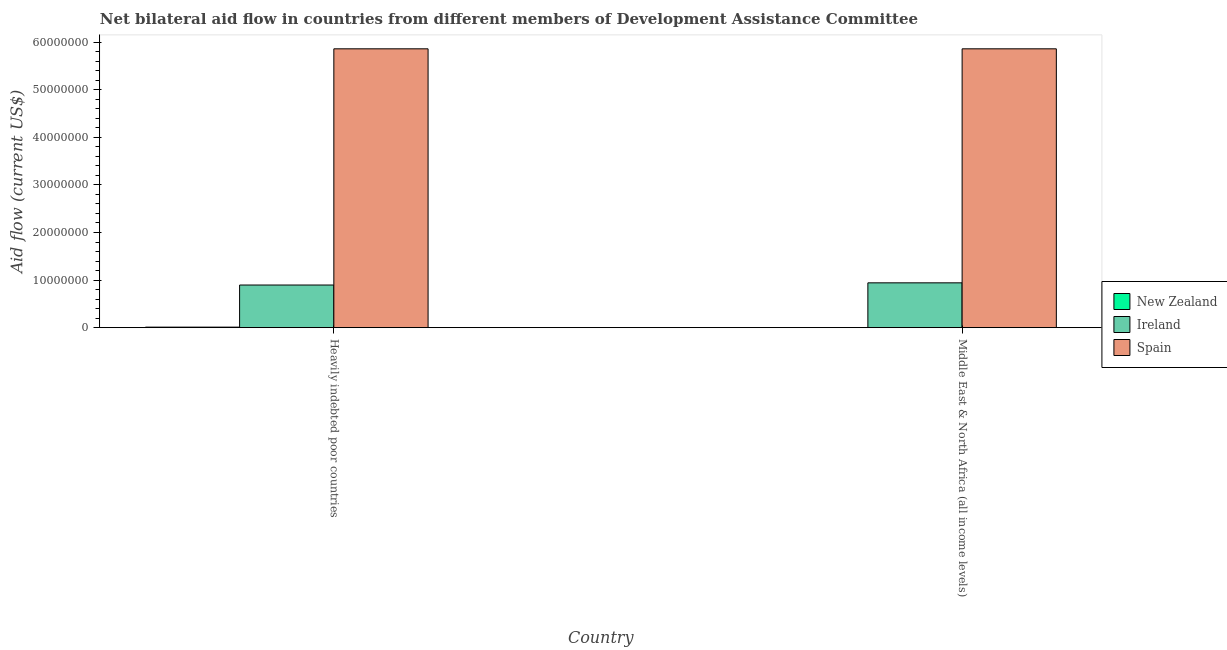How many groups of bars are there?
Offer a very short reply. 2. Are the number of bars on each tick of the X-axis equal?
Provide a succinct answer. Yes. How many bars are there on the 1st tick from the left?
Ensure brevity in your answer.  3. How many bars are there on the 1st tick from the right?
Your answer should be compact. 3. What is the label of the 1st group of bars from the left?
Provide a succinct answer. Heavily indebted poor countries. What is the amount of aid provided by ireland in Middle East & North Africa (all income levels)?
Offer a terse response. 9.42e+06. Across all countries, what is the maximum amount of aid provided by ireland?
Provide a succinct answer. 9.42e+06. Across all countries, what is the minimum amount of aid provided by new zealand?
Your answer should be compact. 3.00e+04. In which country was the amount of aid provided by ireland maximum?
Offer a very short reply. Middle East & North Africa (all income levels). In which country was the amount of aid provided by spain minimum?
Your answer should be very brief. Heavily indebted poor countries. What is the total amount of aid provided by new zealand in the graph?
Ensure brevity in your answer.  1.40e+05. What is the difference between the amount of aid provided by new zealand in Heavily indebted poor countries and that in Middle East & North Africa (all income levels)?
Make the answer very short. 8.00e+04. What is the difference between the amount of aid provided by ireland in Heavily indebted poor countries and the amount of aid provided by spain in Middle East & North Africa (all income levels)?
Keep it short and to the point. -4.96e+07. What is the average amount of aid provided by spain per country?
Make the answer very short. 5.86e+07. What is the difference between the amount of aid provided by ireland and amount of aid provided by new zealand in Middle East & North Africa (all income levels)?
Your response must be concise. 9.39e+06. In how many countries, is the amount of aid provided by ireland greater than 52000000 US$?
Offer a very short reply. 0. Is the amount of aid provided by ireland in Heavily indebted poor countries less than that in Middle East & North Africa (all income levels)?
Provide a short and direct response. Yes. In how many countries, is the amount of aid provided by ireland greater than the average amount of aid provided by ireland taken over all countries?
Provide a succinct answer. 1. What does the 1st bar from the left in Heavily indebted poor countries represents?
Make the answer very short. New Zealand. What does the 2nd bar from the right in Heavily indebted poor countries represents?
Keep it short and to the point. Ireland. Is it the case that in every country, the sum of the amount of aid provided by new zealand and amount of aid provided by ireland is greater than the amount of aid provided by spain?
Provide a succinct answer. No. What is the difference between two consecutive major ticks on the Y-axis?
Provide a succinct answer. 1.00e+07. Does the graph contain any zero values?
Provide a short and direct response. No. Where does the legend appear in the graph?
Provide a succinct answer. Center right. What is the title of the graph?
Your response must be concise. Net bilateral aid flow in countries from different members of Development Assistance Committee. What is the label or title of the Y-axis?
Offer a very short reply. Aid flow (current US$). What is the Aid flow (current US$) of New Zealand in Heavily indebted poor countries?
Your answer should be compact. 1.10e+05. What is the Aid flow (current US$) in Ireland in Heavily indebted poor countries?
Provide a short and direct response. 8.96e+06. What is the Aid flow (current US$) in Spain in Heavily indebted poor countries?
Make the answer very short. 5.86e+07. What is the Aid flow (current US$) of New Zealand in Middle East & North Africa (all income levels)?
Your answer should be compact. 3.00e+04. What is the Aid flow (current US$) in Ireland in Middle East & North Africa (all income levels)?
Your answer should be compact. 9.42e+06. What is the Aid flow (current US$) in Spain in Middle East & North Africa (all income levels)?
Keep it short and to the point. 5.86e+07. Across all countries, what is the maximum Aid flow (current US$) of Ireland?
Make the answer very short. 9.42e+06. Across all countries, what is the maximum Aid flow (current US$) in Spain?
Your answer should be compact. 5.86e+07. Across all countries, what is the minimum Aid flow (current US$) in Ireland?
Give a very brief answer. 8.96e+06. Across all countries, what is the minimum Aid flow (current US$) of Spain?
Provide a succinct answer. 5.86e+07. What is the total Aid flow (current US$) of New Zealand in the graph?
Your answer should be very brief. 1.40e+05. What is the total Aid flow (current US$) in Ireland in the graph?
Your answer should be very brief. 1.84e+07. What is the total Aid flow (current US$) of Spain in the graph?
Offer a very short reply. 1.17e+08. What is the difference between the Aid flow (current US$) in New Zealand in Heavily indebted poor countries and that in Middle East & North Africa (all income levels)?
Provide a short and direct response. 8.00e+04. What is the difference between the Aid flow (current US$) of Ireland in Heavily indebted poor countries and that in Middle East & North Africa (all income levels)?
Your answer should be compact. -4.60e+05. What is the difference between the Aid flow (current US$) in Spain in Heavily indebted poor countries and that in Middle East & North Africa (all income levels)?
Your answer should be compact. 0. What is the difference between the Aid flow (current US$) of New Zealand in Heavily indebted poor countries and the Aid flow (current US$) of Ireland in Middle East & North Africa (all income levels)?
Your answer should be compact. -9.31e+06. What is the difference between the Aid flow (current US$) in New Zealand in Heavily indebted poor countries and the Aid flow (current US$) in Spain in Middle East & North Africa (all income levels)?
Your answer should be compact. -5.85e+07. What is the difference between the Aid flow (current US$) in Ireland in Heavily indebted poor countries and the Aid flow (current US$) in Spain in Middle East & North Africa (all income levels)?
Give a very brief answer. -4.96e+07. What is the average Aid flow (current US$) of Ireland per country?
Your answer should be compact. 9.19e+06. What is the average Aid flow (current US$) in Spain per country?
Your response must be concise. 5.86e+07. What is the difference between the Aid flow (current US$) of New Zealand and Aid flow (current US$) of Ireland in Heavily indebted poor countries?
Keep it short and to the point. -8.85e+06. What is the difference between the Aid flow (current US$) of New Zealand and Aid flow (current US$) of Spain in Heavily indebted poor countries?
Your response must be concise. -5.85e+07. What is the difference between the Aid flow (current US$) in Ireland and Aid flow (current US$) in Spain in Heavily indebted poor countries?
Your answer should be very brief. -4.96e+07. What is the difference between the Aid flow (current US$) of New Zealand and Aid flow (current US$) of Ireland in Middle East & North Africa (all income levels)?
Your response must be concise. -9.39e+06. What is the difference between the Aid flow (current US$) of New Zealand and Aid flow (current US$) of Spain in Middle East & North Africa (all income levels)?
Your answer should be compact. -5.86e+07. What is the difference between the Aid flow (current US$) in Ireland and Aid flow (current US$) in Spain in Middle East & North Africa (all income levels)?
Provide a succinct answer. -4.92e+07. What is the ratio of the Aid flow (current US$) of New Zealand in Heavily indebted poor countries to that in Middle East & North Africa (all income levels)?
Offer a terse response. 3.67. What is the ratio of the Aid flow (current US$) of Ireland in Heavily indebted poor countries to that in Middle East & North Africa (all income levels)?
Provide a succinct answer. 0.95. What is the ratio of the Aid flow (current US$) in Spain in Heavily indebted poor countries to that in Middle East & North Africa (all income levels)?
Keep it short and to the point. 1. What is the difference between the highest and the second highest Aid flow (current US$) in New Zealand?
Your response must be concise. 8.00e+04. What is the difference between the highest and the second highest Aid flow (current US$) in Spain?
Keep it short and to the point. 0. What is the difference between the highest and the lowest Aid flow (current US$) of New Zealand?
Ensure brevity in your answer.  8.00e+04. What is the difference between the highest and the lowest Aid flow (current US$) of Ireland?
Your response must be concise. 4.60e+05. What is the difference between the highest and the lowest Aid flow (current US$) in Spain?
Provide a short and direct response. 0. 